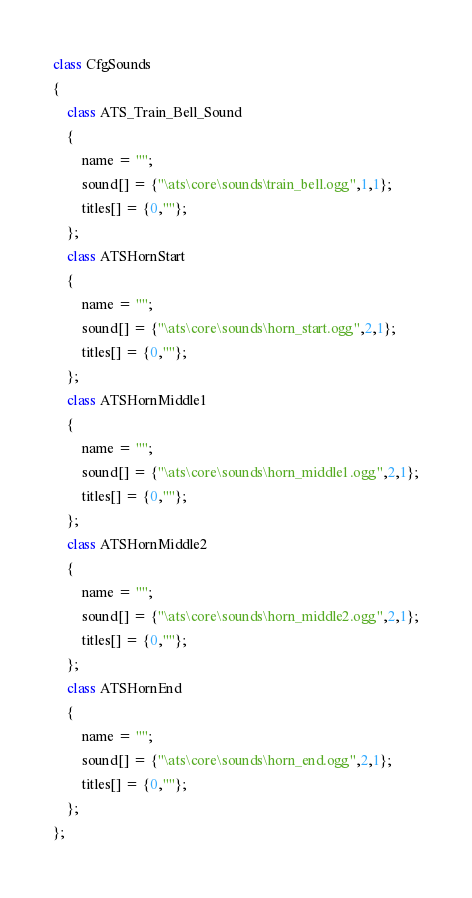Convert code to text. <code><loc_0><loc_0><loc_500><loc_500><_C++_>class CfgSounds
{
    class ATS_Train_Bell_Sound
    {
        name = "";
        sound[] = {"\ats\core\sounds\train_bell.ogg",1,1};
        titles[] = {0,""};
    };
    class ATSHornStart
    {
        name = "";
        sound[] = {"\ats\core\sounds\horn_start.ogg",2,1};
        titles[] = {0,""};
    };
    class ATSHornMiddle1
    {
        name = "";
        sound[] = {"\ats\core\sounds\horn_middle1.ogg",2,1};
        titles[] = {0,""};
    };
    class ATSHornMiddle2
    {
        name = "";
        sound[] = {"\ats\core\sounds\horn_middle2.ogg",2,1};
        titles[] = {0,""};
    };
    class ATSHornEnd
    {
        name = "";
        sound[] = {"\ats\core\sounds\horn_end.ogg",2,1};
        titles[] = {0,""};
    };
};
</code> 